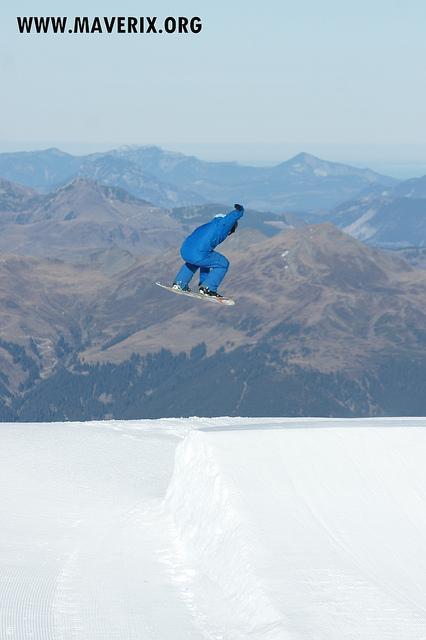How many benches are in the picture?
Give a very brief answer. 0. 